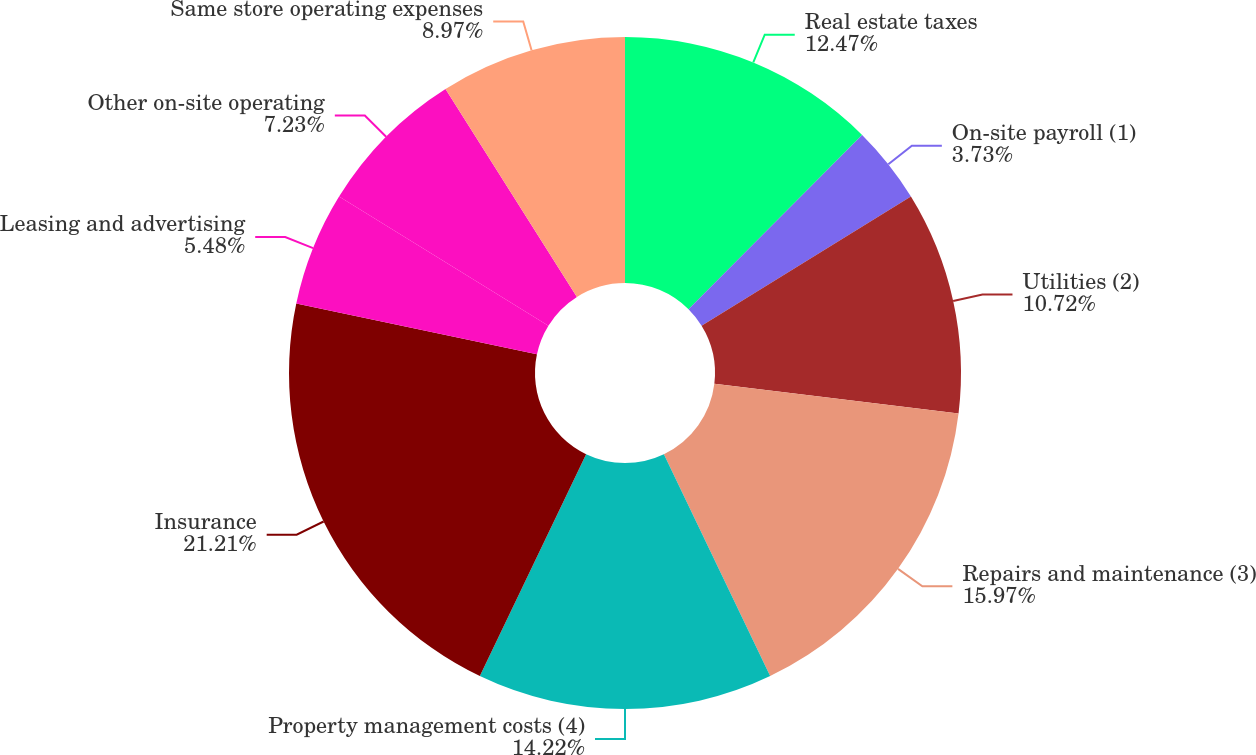Convert chart to OTSL. <chart><loc_0><loc_0><loc_500><loc_500><pie_chart><fcel>Real estate taxes<fcel>On-site payroll (1)<fcel>Utilities (2)<fcel>Repairs and maintenance (3)<fcel>Property management costs (4)<fcel>Insurance<fcel>Leasing and advertising<fcel>Other on-site operating<fcel>Same store operating expenses<nl><fcel>12.47%<fcel>3.73%<fcel>10.72%<fcel>15.97%<fcel>14.22%<fcel>21.21%<fcel>5.48%<fcel>7.23%<fcel>8.97%<nl></chart> 